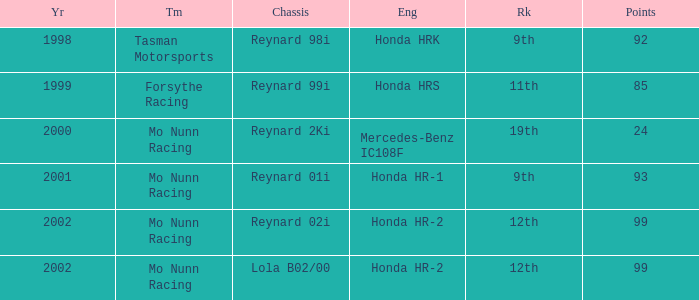What is the rank of the reynard 2ki chassis before 2002? 19th. 